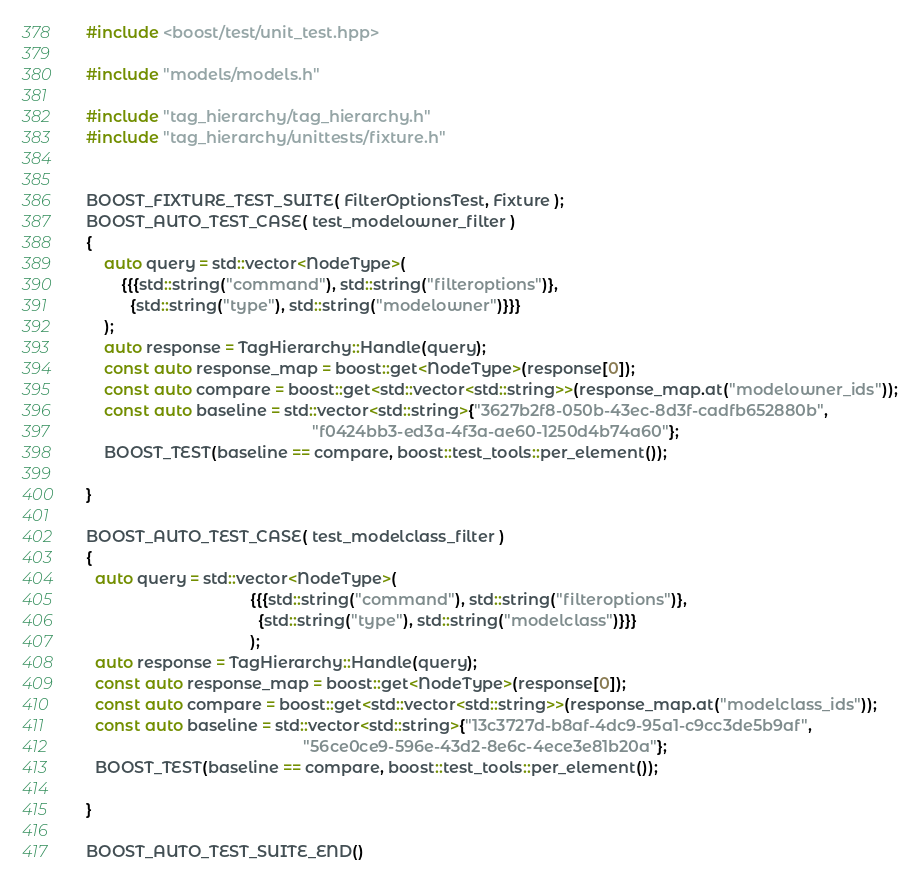Convert code to text. <code><loc_0><loc_0><loc_500><loc_500><_C++_>#include <boost/test/unit_test.hpp>

#include "models/models.h"

#include "tag_hierarchy/tag_hierarchy.h"
#include "tag_hierarchy/unittests/fixture.h"


BOOST_FIXTURE_TEST_SUITE( FilterOptionsTest, Fixture );
BOOST_AUTO_TEST_CASE( test_modelowner_filter )
{
    auto query = std::vector<NodeType>(
        {{{std::string("command"), std::string("filteroptions")},
          {std::string("type"), std::string("modelowner")}}}
    );
    auto response = TagHierarchy::Handle(query);
    const auto response_map = boost::get<NodeType>(response[0]);
    const auto compare = boost::get<std::vector<std::string>>(response_map.at("modelowner_ids"));
    const auto baseline = std::vector<std::string>{"3627b2f8-050b-43ec-8d3f-cadfb652880b",
                                                   "f0424bb3-ed3a-4f3a-ae60-1250d4b74a60"};
    BOOST_TEST(baseline == compare, boost::test_tools::per_element());

}

BOOST_AUTO_TEST_CASE( test_modelclass_filter )
{
  auto query = std::vector<NodeType>(
                                     {{{std::string("command"), std::string("filteroptions")},
                                       {std::string("type"), std::string("modelclass")}}}
                                     );
  auto response = TagHierarchy::Handle(query);
  const auto response_map = boost::get<NodeType>(response[0]);
  const auto compare = boost::get<std::vector<std::string>>(response_map.at("modelclass_ids"));
  const auto baseline = std::vector<std::string>{"13c3727d-b8af-4dc9-95a1-c9cc3de5b9af",
                                                 "56ce0ce9-596e-43d2-8e6c-4ece3e81b20a"};
  BOOST_TEST(baseline == compare, boost::test_tools::per_element());

}

BOOST_AUTO_TEST_SUITE_END()
</code> 